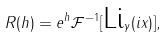Convert formula to latex. <formula><loc_0><loc_0><loc_500><loc_500>R ( h ) = e ^ { h } \mathcal { F } ^ { - 1 } [ { \mbox L } { \mbox i } _ { \gamma } ( i x ) ] ,</formula> 